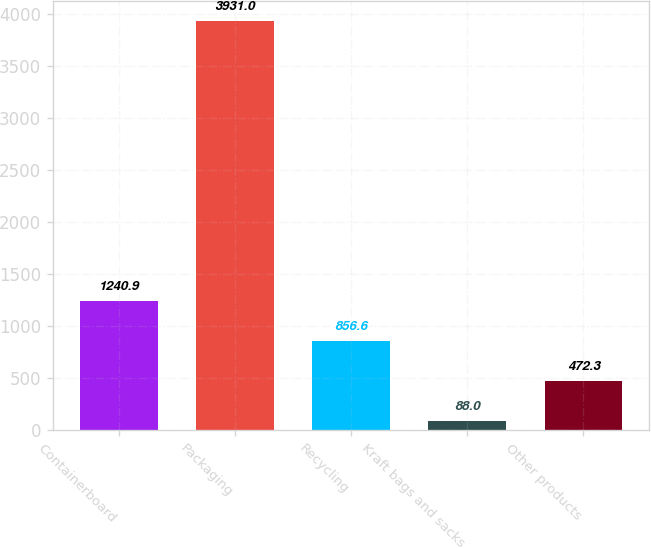Convert chart to OTSL. <chart><loc_0><loc_0><loc_500><loc_500><bar_chart><fcel>Containerboard<fcel>Packaging<fcel>Recycling<fcel>Kraft bags and sacks<fcel>Other products<nl><fcel>1240.9<fcel>3931<fcel>856.6<fcel>88<fcel>472.3<nl></chart> 